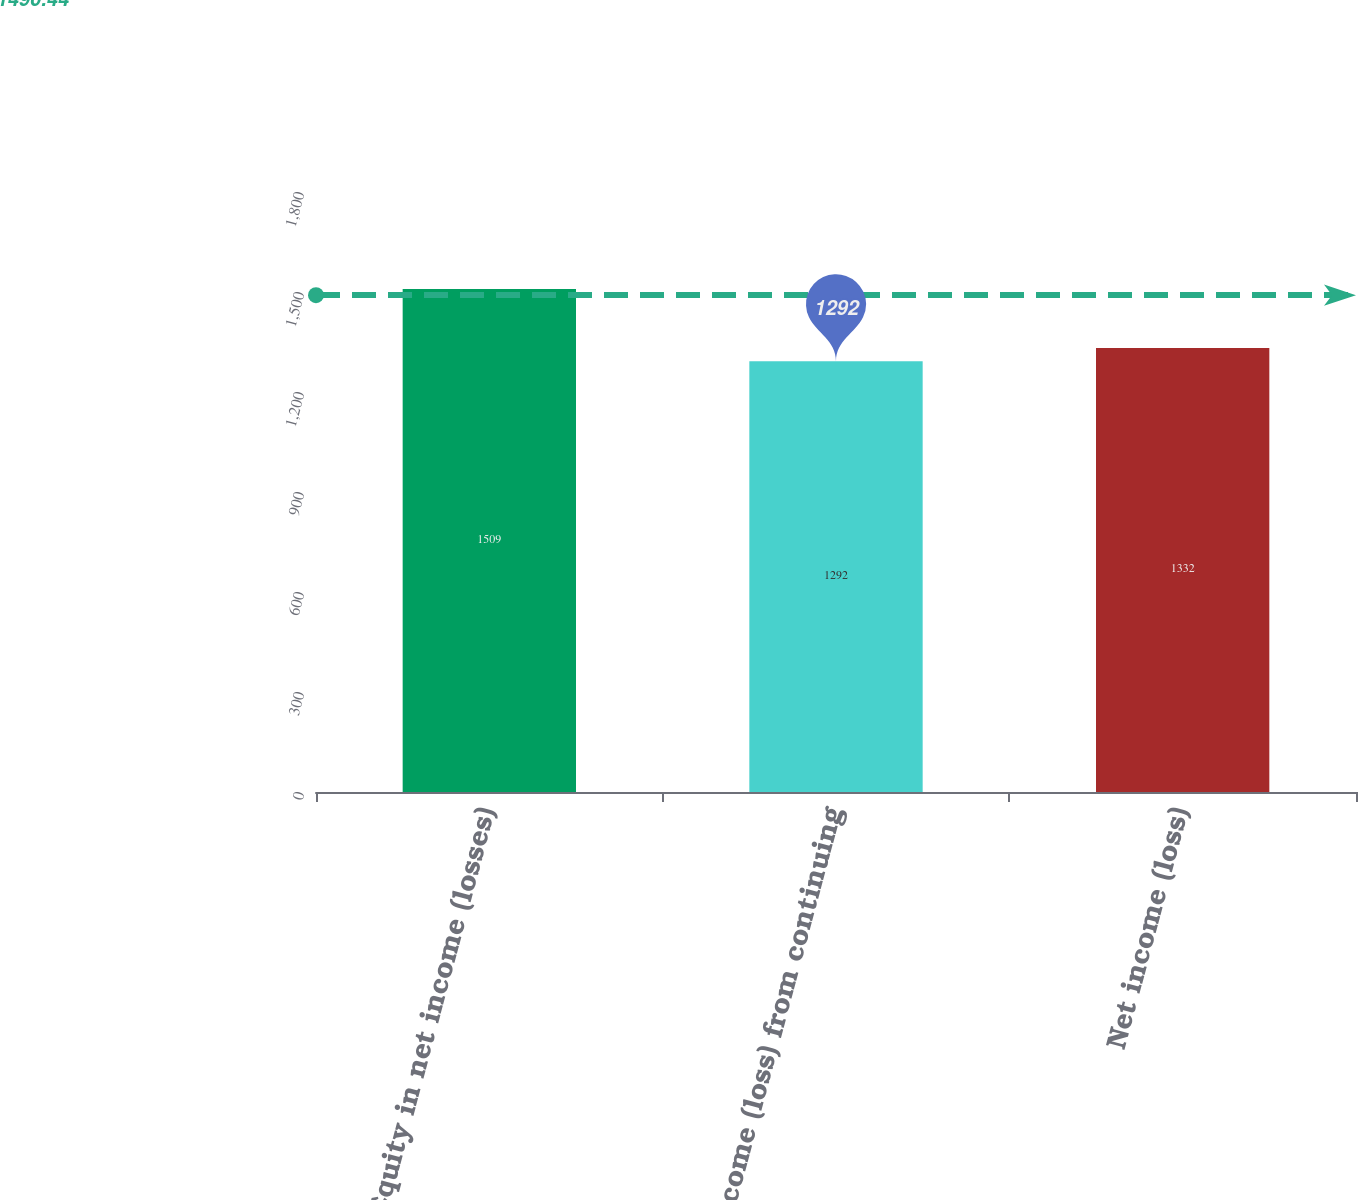Convert chart. <chart><loc_0><loc_0><loc_500><loc_500><bar_chart><fcel>Equity in net income (losses)<fcel>Income (loss) from continuing<fcel>Net income (loss)<nl><fcel>1509<fcel>1292<fcel>1332<nl></chart> 